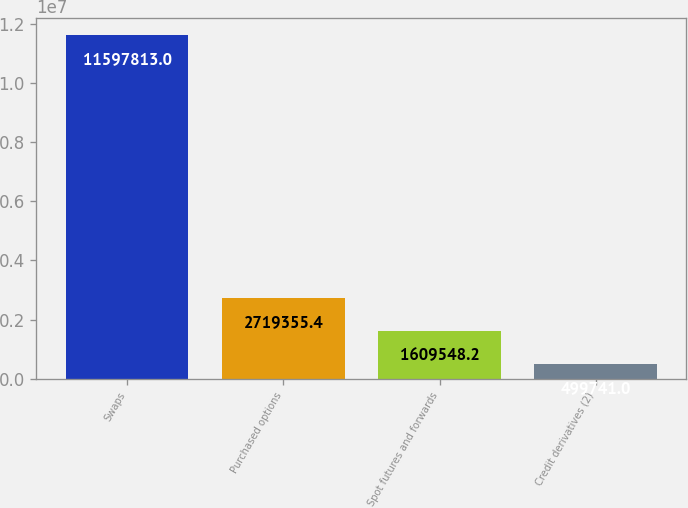<chart> <loc_0><loc_0><loc_500><loc_500><bar_chart><fcel>Swaps<fcel>Purchased options<fcel>Spot futures and forwards<fcel>Credit derivatives (2)<nl><fcel>1.15978e+07<fcel>2.71936e+06<fcel>1.60955e+06<fcel>499741<nl></chart> 